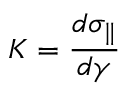<formula> <loc_0><loc_0><loc_500><loc_500>K = \frac { d \sigma _ { \| } } { d \gamma }</formula> 